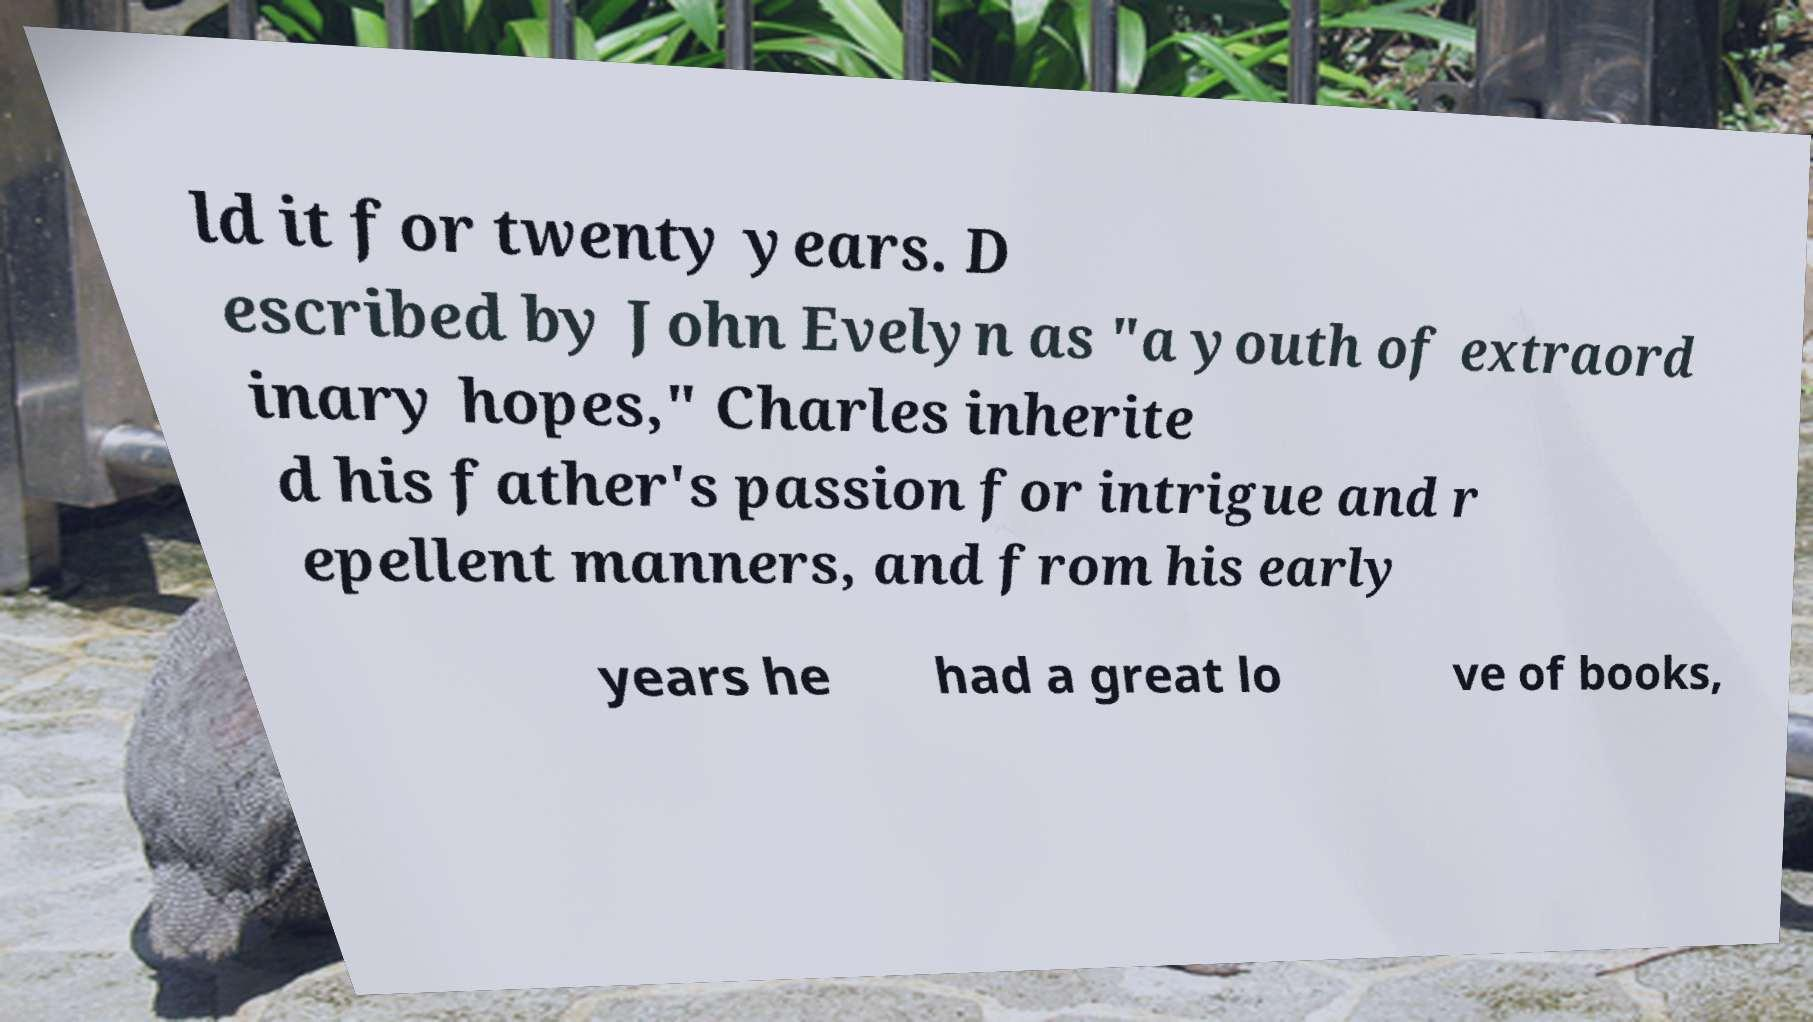Could you assist in decoding the text presented in this image and type it out clearly? ld it for twenty years. D escribed by John Evelyn as "a youth of extraord inary hopes," Charles inherite d his father's passion for intrigue and r epellent manners, and from his early years he had a great lo ve of books, 